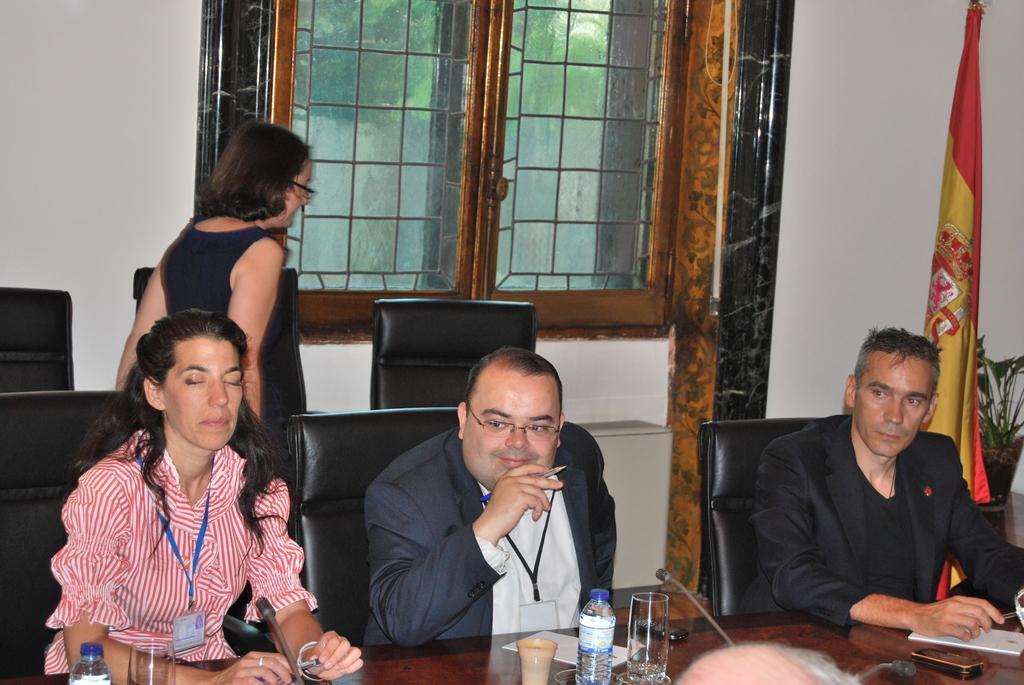Could you give a brief overview of what you see in this image? This is inside a meeting hall. There are four persons on the image. One lady is standing other three are sitting on their chairs. In front of them there is a table. On the table there is bottle,glass,mi,pen,paper. On the right side there is a flag beside it there is a plant pot. In the background there is a window. Through the window glass I can see trees. 